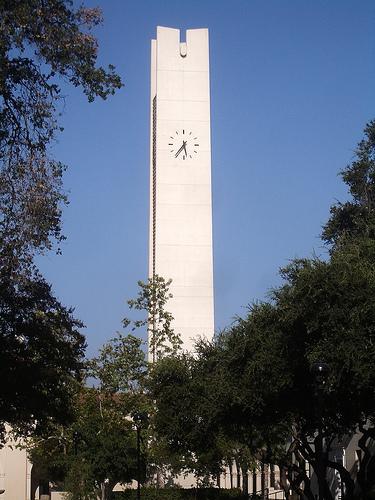Is there a bell tower?
Be succinct. No. Sunny or overcast?
Quick response, please. Sunny. What time does the clock say?
Write a very short answer. 5:35. Are clouds in the sky?
Answer briefly. No. Are there any clouds in the sky?
Write a very short answer. No. What time is it?
Write a very short answer. 5:35. Is it a clear day?
Answer briefly. Yes. What monument is this?
Answer briefly. Clock tower. Is the tower pointed?
Keep it brief. No. Is this a very tall structure?
Answer briefly. Yes. What size is the clock on the clock tower?
Short answer required. Large. What monument is shown?
Write a very short answer. Clock tower. 